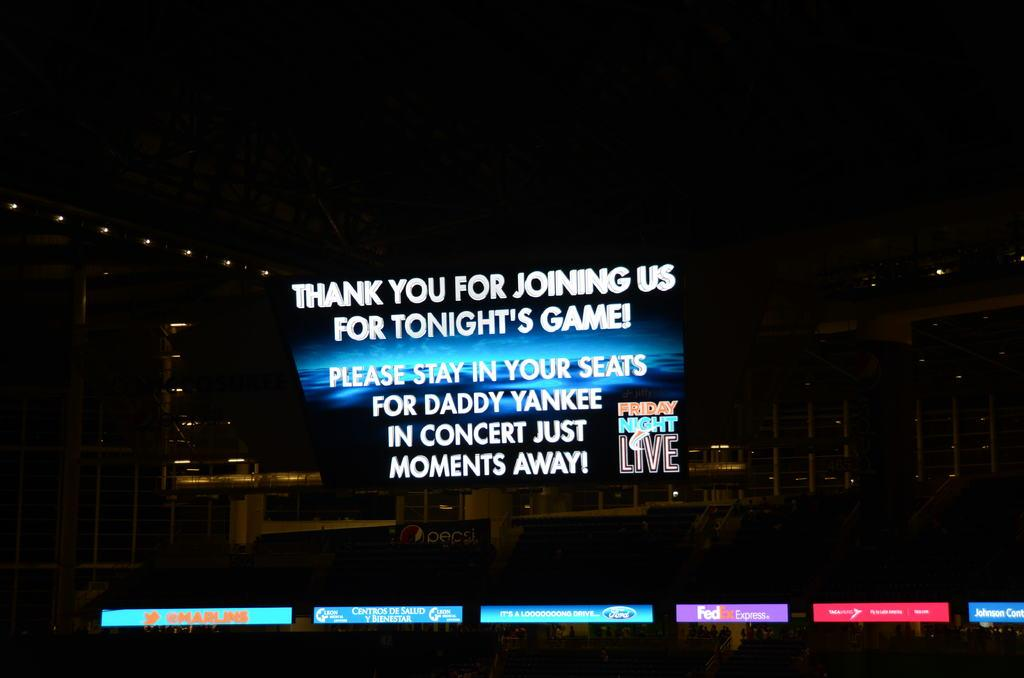Provide a one-sentence caption for the provided image. A television screen has Friday Night Live on the monitor with advertisements under it. 